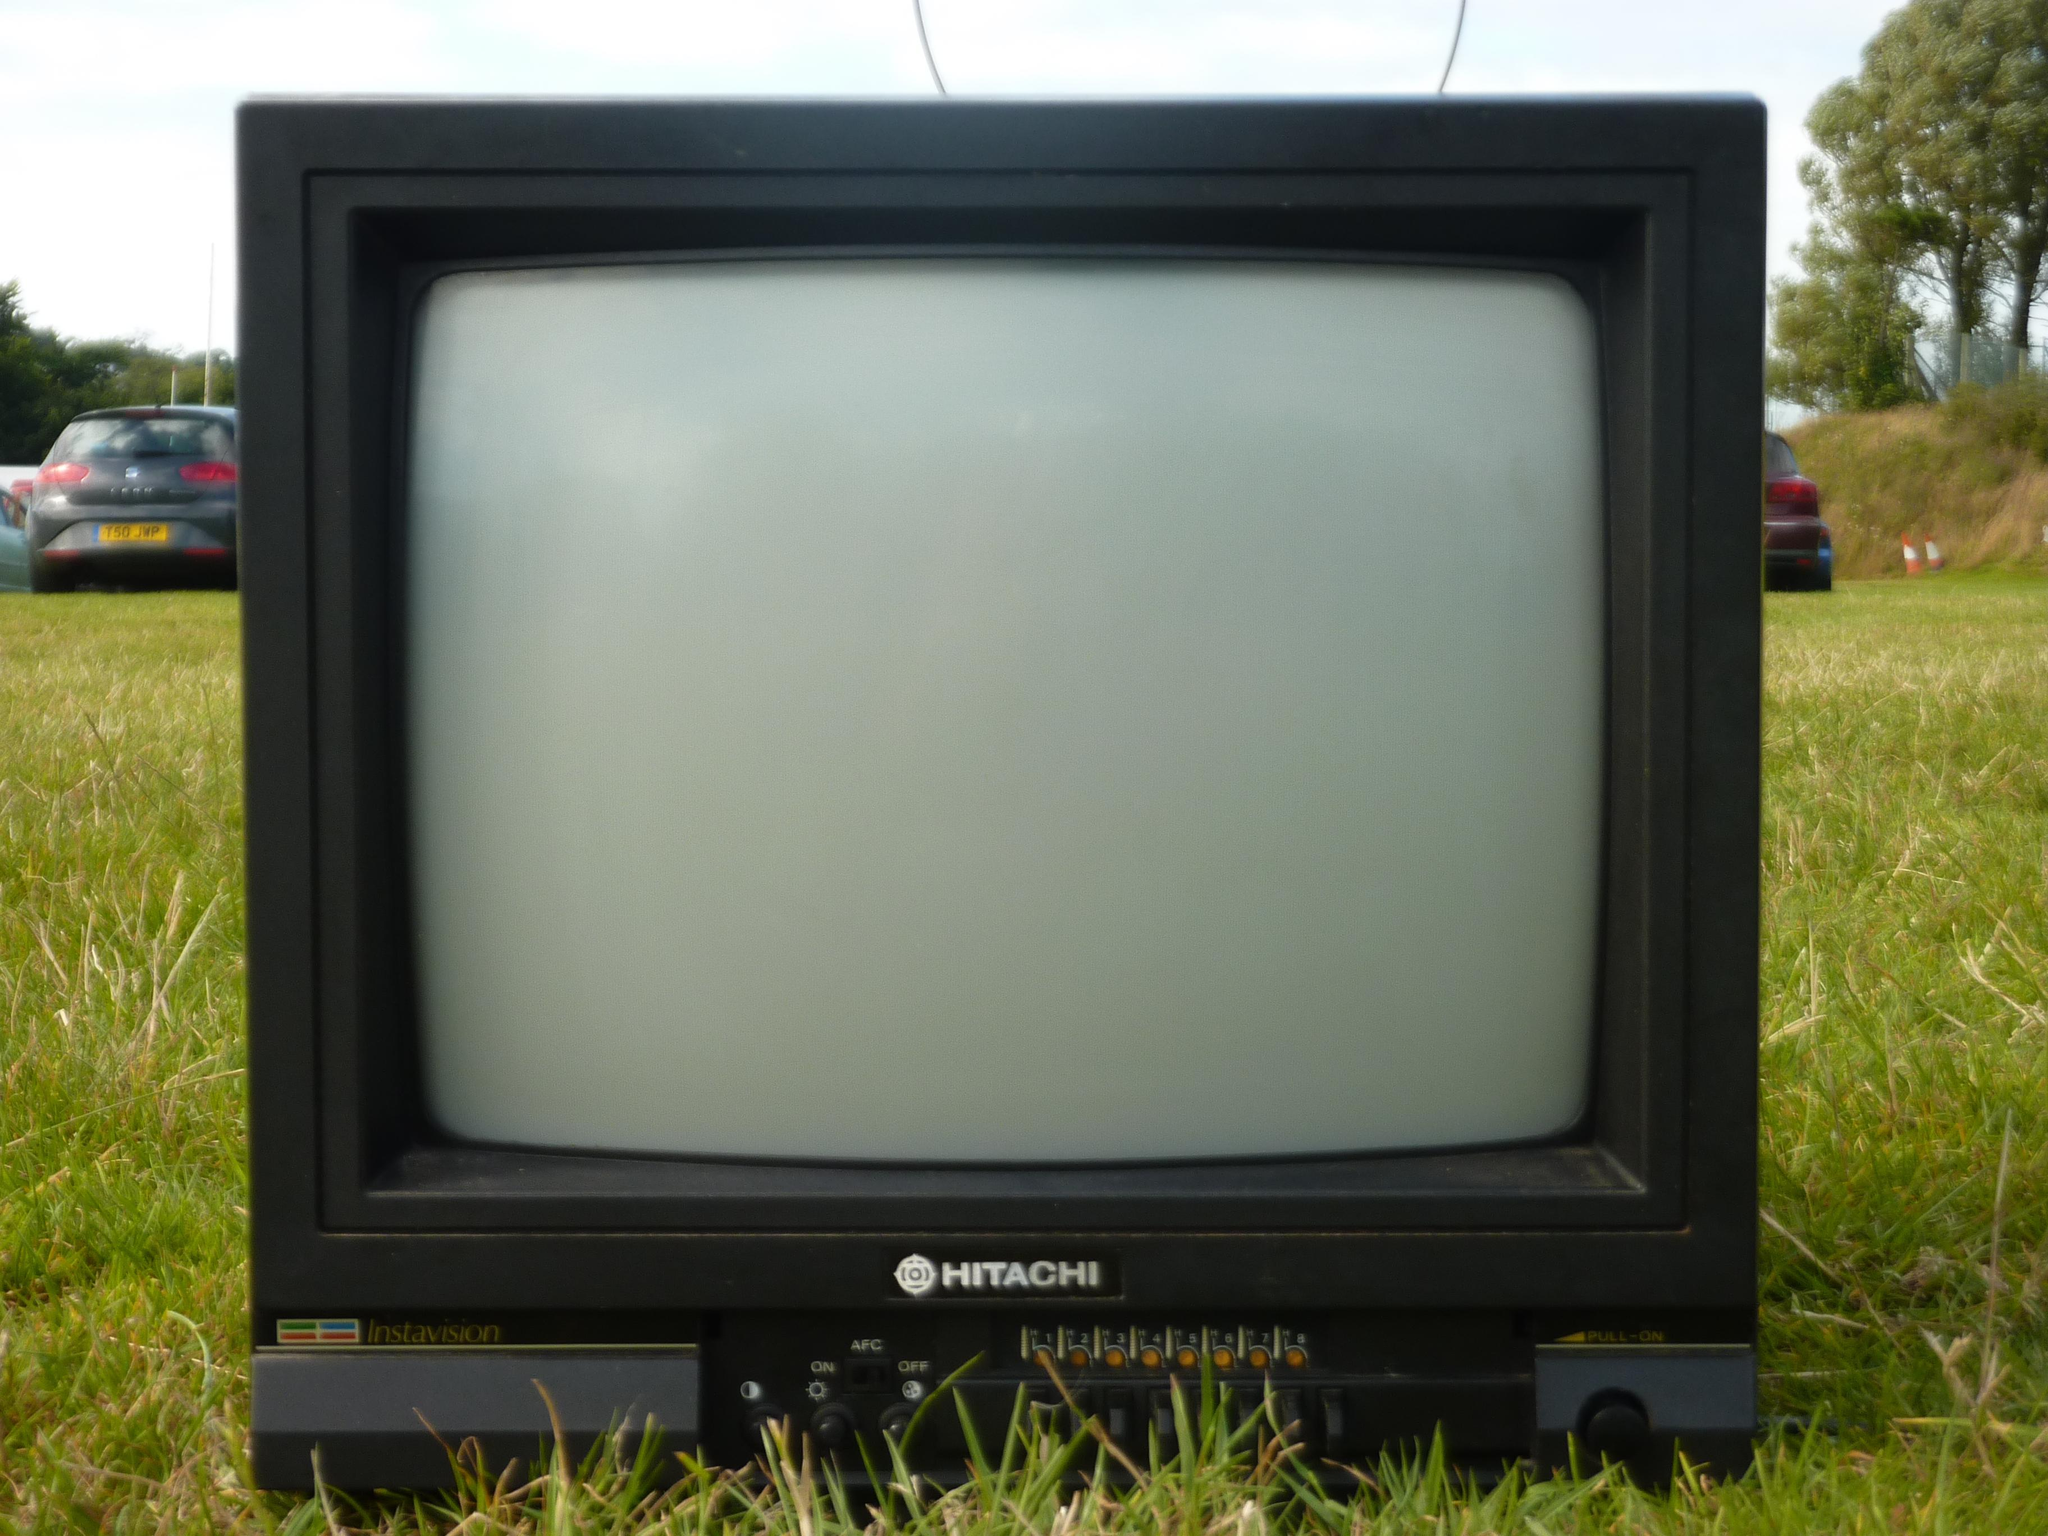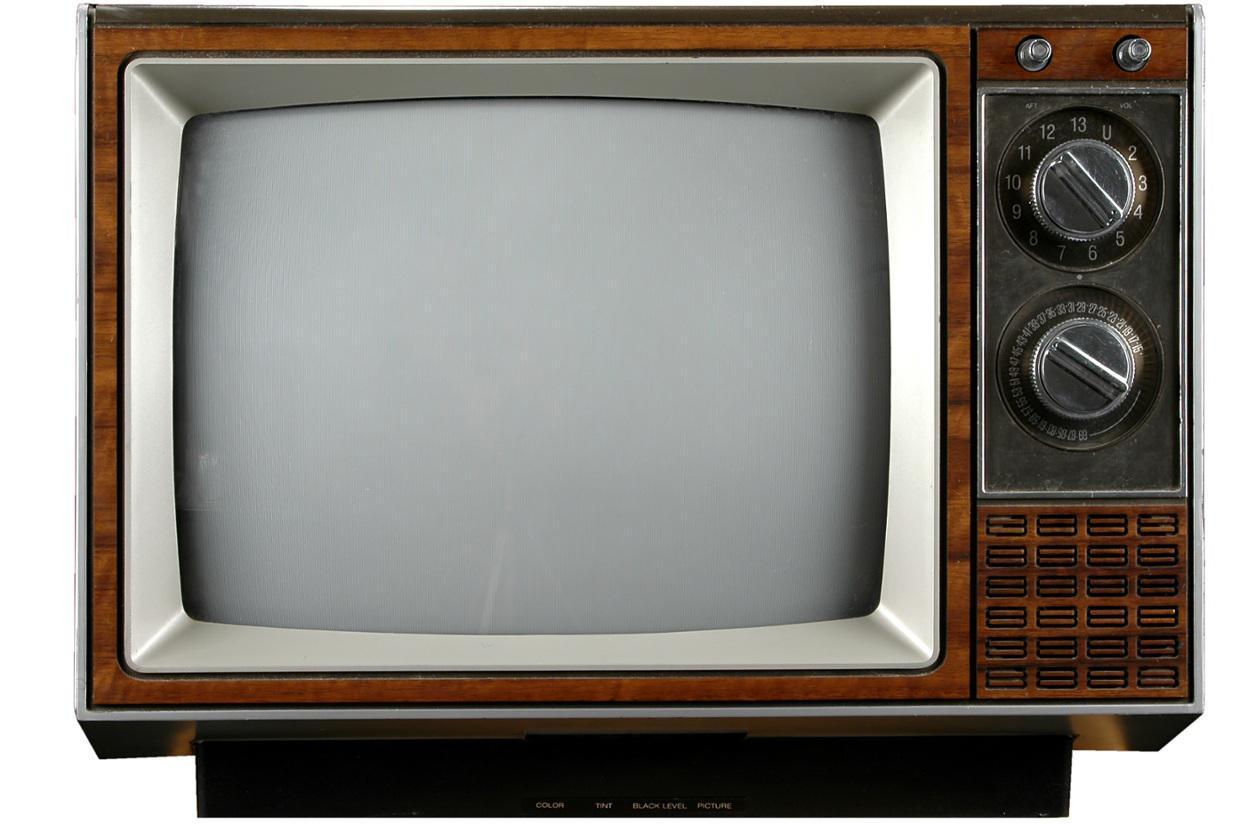The first image is the image on the left, the second image is the image on the right. Considering the images on both sides, is "One TV is sitting outside with grass and trees in the background." valid? Answer yes or no. Yes. The first image is the image on the left, the second image is the image on the right. Considering the images on both sides, is "One TV has three small knobs in a horizontal row at the bottom right and two black rectangles arranged one over the other on the upper right." valid? Answer yes or no. No. 